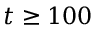<formula> <loc_0><loc_0><loc_500><loc_500>t \geq 1 0 0</formula> 